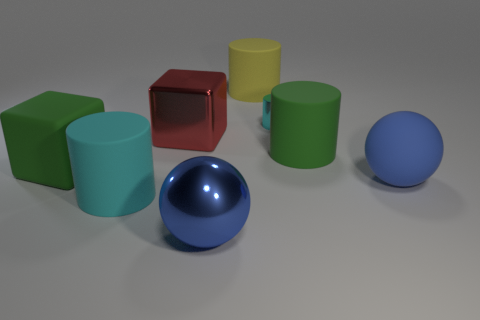Add 1 cyan matte things. How many objects exist? 9 Subtract all cubes. How many objects are left? 6 Subtract all gray objects. Subtract all big green blocks. How many objects are left? 7 Add 2 matte blocks. How many matte blocks are left? 3 Add 4 blue metallic spheres. How many blue metallic spheres exist? 5 Subtract 0 blue cubes. How many objects are left? 8 